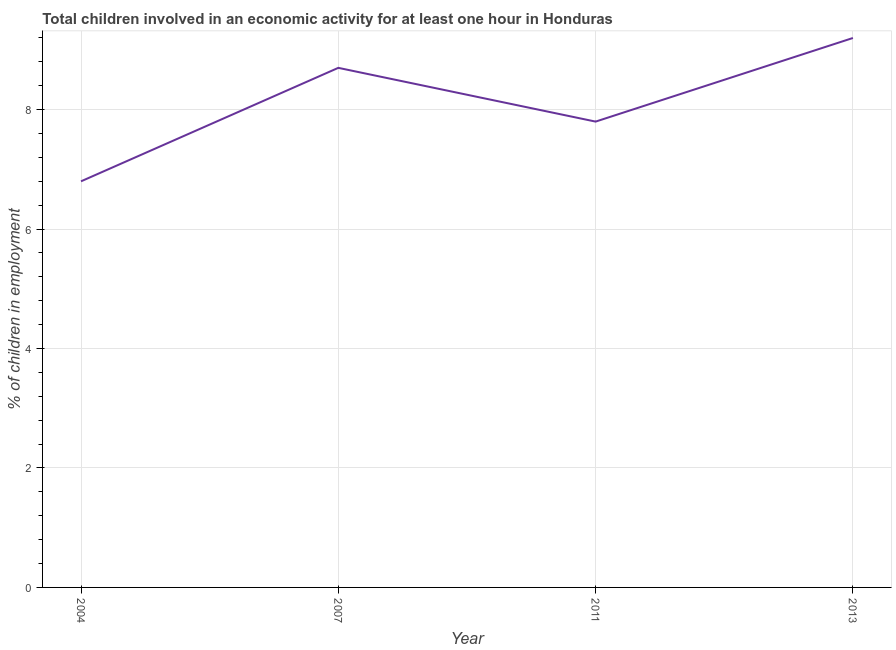Across all years, what is the maximum percentage of children in employment?
Ensure brevity in your answer.  9.2. In which year was the percentage of children in employment maximum?
Your answer should be very brief. 2013. What is the sum of the percentage of children in employment?
Keep it short and to the point. 32.5. What is the difference between the percentage of children in employment in 2007 and 2011?
Your answer should be very brief. 0.9. What is the average percentage of children in employment per year?
Give a very brief answer. 8.12. What is the median percentage of children in employment?
Provide a short and direct response. 8.25. In how many years, is the percentage of children in employment greater than 6.8 %?
Your response must be concise. 3. What is the ratio of the percentage of children in employment in 2004 to that in 2007?
Your answer should be compact. 0.78. Is the percentage of children in employment in 2004 less than that in 2013?
Your response must be concise. Yes. What is the difference between the highest and the second highest percentage of children in employment?
Provide a short and direct response. 0.5. What is the difference between the highest and the lowest percentage of children in employment?
Offer a very short reply. 2.4. In how many years, is the percentage of children in employment greater than the average percentage of children in employment taken over all years?
Ensure brevity in your answer.  2. Does the percentage of children in employment monotonically increase over the years?
Your answer should be compact. No. How many lines are there?
Your response must be concise. 1. How many years are there in the graph?
Your answer should be compact. 4. Does the graph contain any zero values?
Offer a very short reply. No. Does the graph contain grids?
Ensure brevity in your answer.  Yes. What is the title of the graph?
Provide a short and direct response. Total children involved in an economic activity for at least one hour in Honduras. What is the label or title of the X-axis?
Provide a short and direct response. Year. What is the label or title of the Y-axis?
Keep it short and to the point. % of children in employment. What is the % of children in employment in 2004?
Offer a terse response. 6.8. What is the % of children in employment in 2011?
Keep it short and to the point. 7.8. What is the difference between the % of children in employment in 2004 and 2007?
Make the answer very short. -1.9. What is the difference between the % of children in employment in 2004 and 2013?
Provide a short and direct response. -2.4. What is the ratio of the % of children in employment in 2004 to that in 2007?
Your answer should be compact. 0.78. What is the ratio of the % of children in employment in 2004 to that in 2011?
Your answer should be very brief. 0.87. What is the ratio of the % of children in employment in 2004 to that in 2013?
Give a very brief answer. 0.74. What is the ratio of the % of children in employment in 2007 to that in 2011?
Provide a succinct answer. 1.11. What is the ratio of the % of children in employment in 2007 to that in 2013?
Your response must be concise. 0.95. What is the ratio of the % of children in employment in 2011 to that in 2013?
Offer a very short reply. 0.85. 